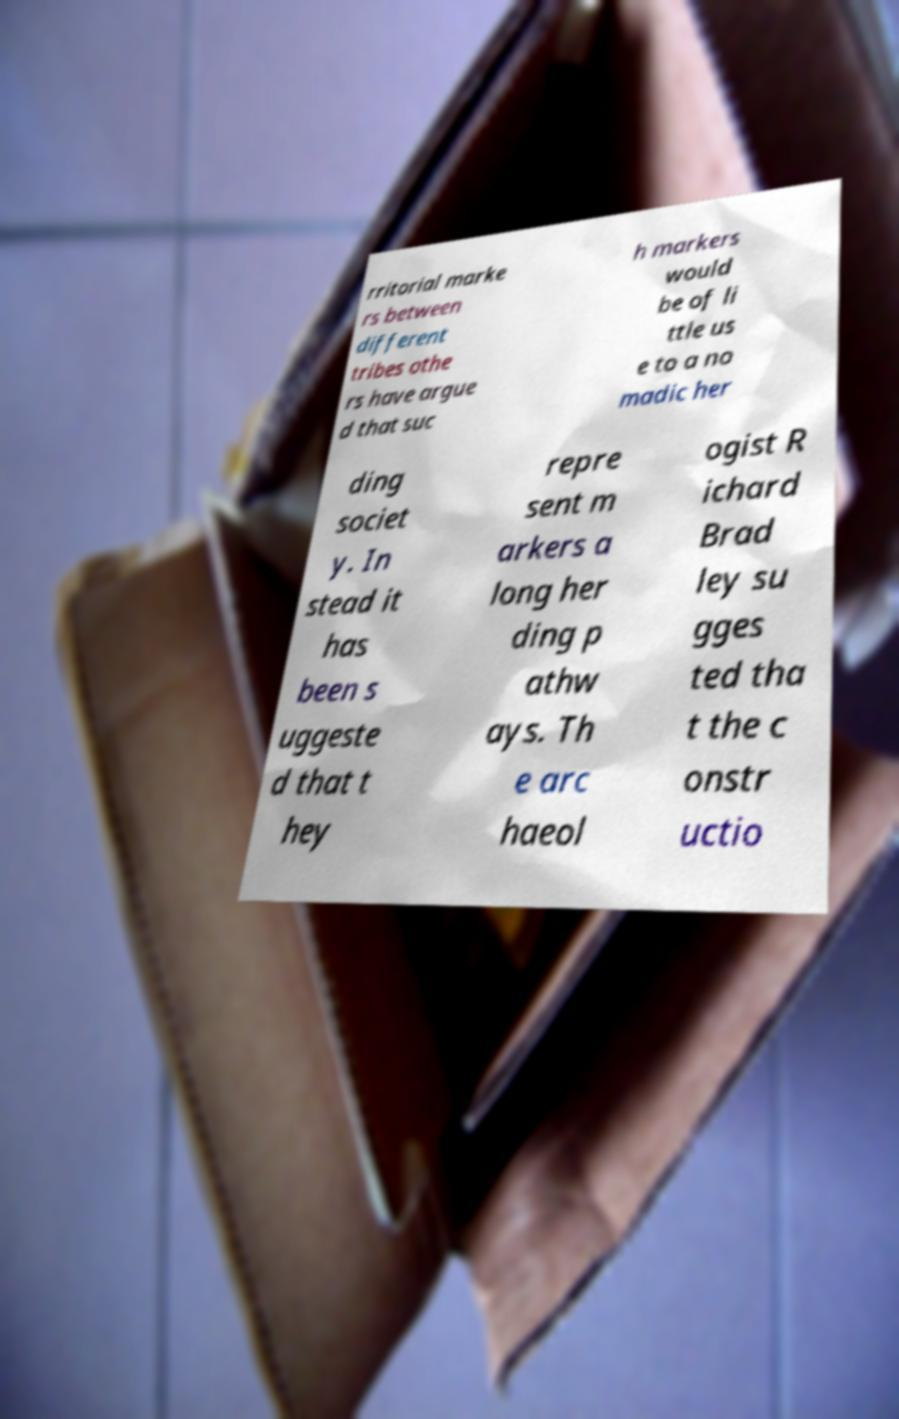I need the written content from this picture converted into text. Can you do that? rritorial marke rs between different tribes othe rs have argue d that suc h markers would be of li ttle us e to a no madic her ding societ y. In stead it has been s uggeste d that t hey repre sent m arkers a long her ding p athw ays. Th e arc haeol ogist R ichard Brad ley su gges ted tha t the c onstr uctio 